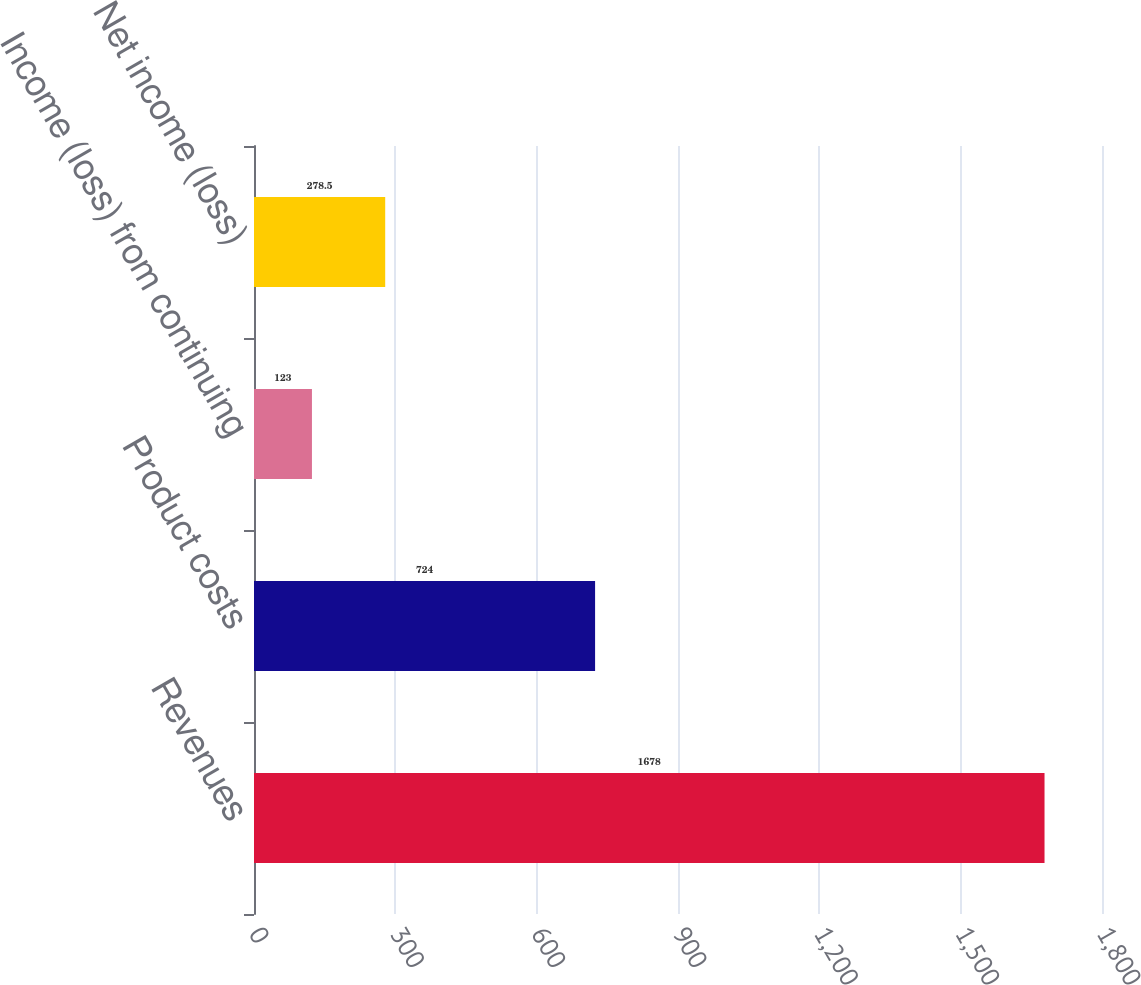Convert chart. <chart><loc_0><loc_0><loc_500><loc_500><bar_chart><fcel>Revenues<fcel>Product costs<fcel>Income (loss) from continuing<fcel>Net income (loss)<nl><fcel>1678<fcel>724<fcel>123<fcel>278.5<nl></chart> 